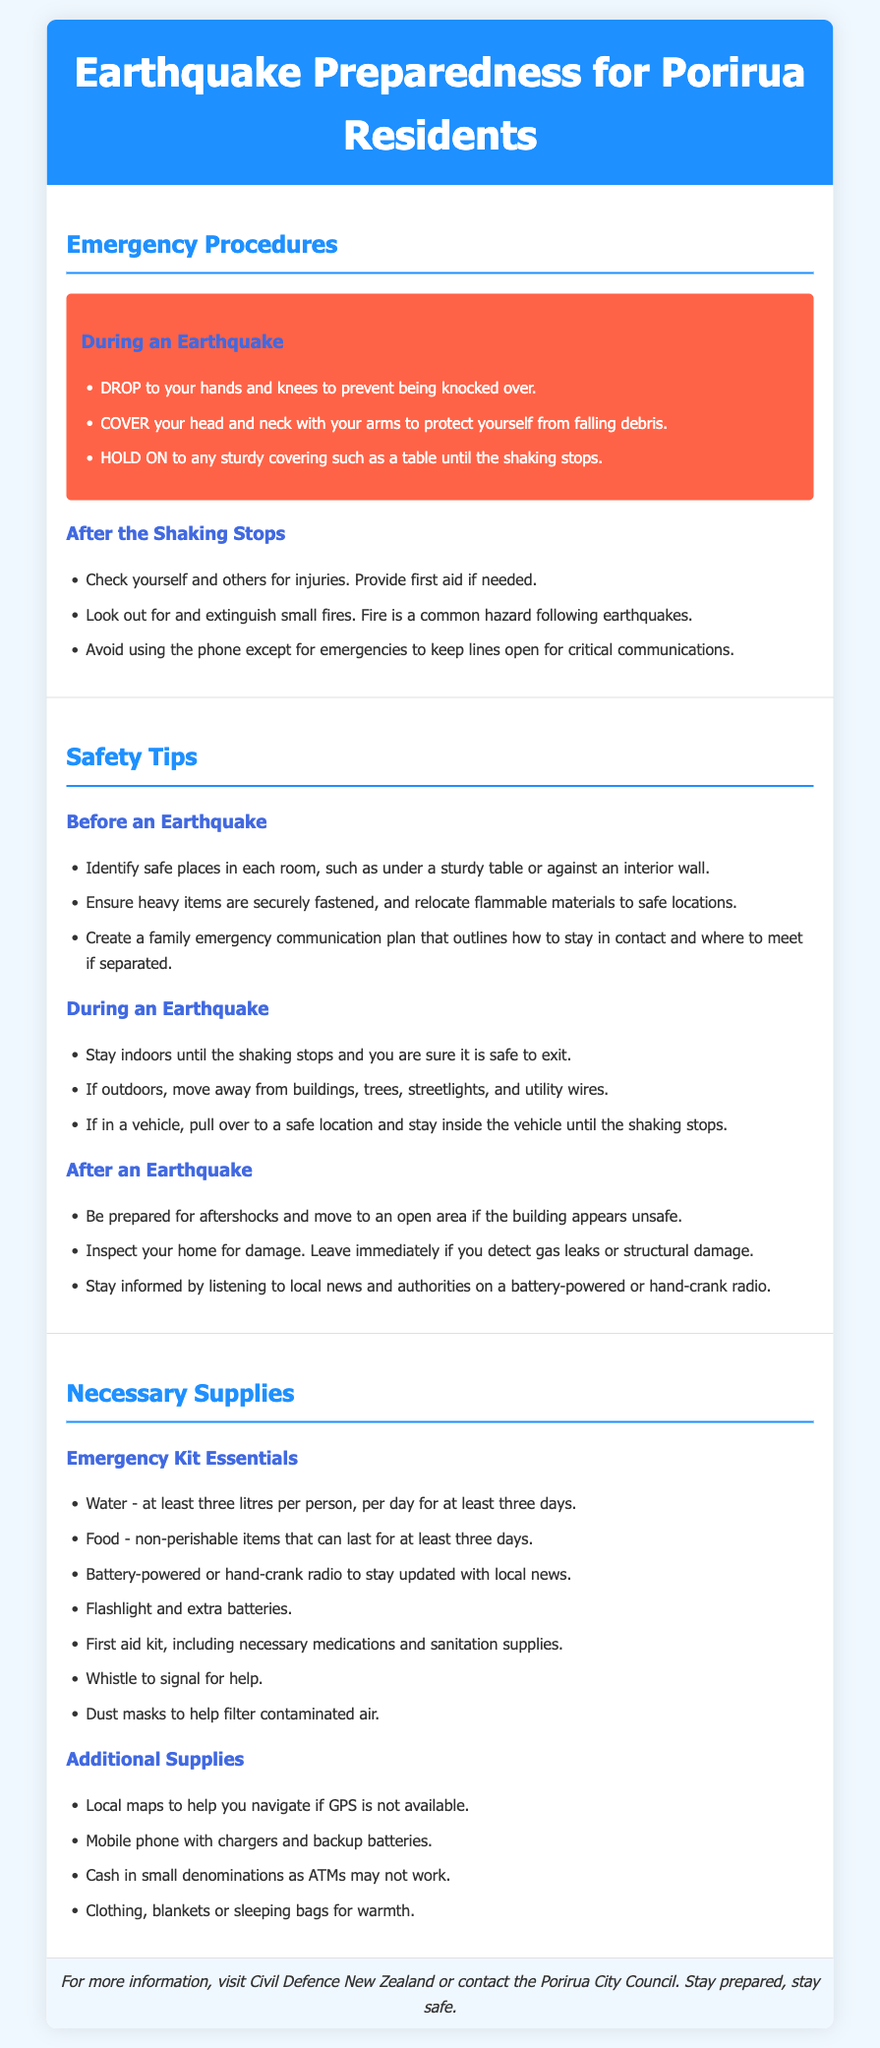What should you do during an earthquake? The document lists specific actions to take during an earthquake, including "DROP," "COVER," and "HOLD ON."
Answer: DROP, COVER, HOLD ON What essentials are recommended for an emergency kit? The document outlines necessary supplies, including water, food, a battery-powered radio, and a first aid kit as part of the emergency kit essentials.
Answer: Water, food, battery-powered radio, first aid kit How many litres of water are needed per person per day? The document specifies that at least three litres of water per person per day are required for at least three days.
Answer: Three litres What is a safety tip to consider before an earthquake? The document suggests identifying safe places in each room and ensuring heavy items are secured as a safety tip before an earthquake.
Answer: Identify safe places, secure heavy items What should you check for after the shaking stops? The document recommends checking yourself and others for injuries and looking out for small fires as part of the aftershock safety measures.
Answer: Check for injuries, small fires What should you avoid using except for emergencies after an earthquake? The document advises avoiding phone use except for emergencies to keep communications open for critical messages.
Answer: Phone What type of radio is important to have in your emergency supplies? The document emphasizes the importance of having a battery-powered or hand-crank radio to stay updated with local news in case of an emergency.
Answer: Battery-powered or hand-crank radio What is a recommended action if gas leaks or structural damage is found? The document advises leaving immediately if gas leaks or structural damage are detected after an earthquake.
Answer: Leave immediately What is the footer's message to residents? The footer serves as a resource for further information and emphasizes the importance of being prepared and safe.
Answer: Stay prepared, stay safe 